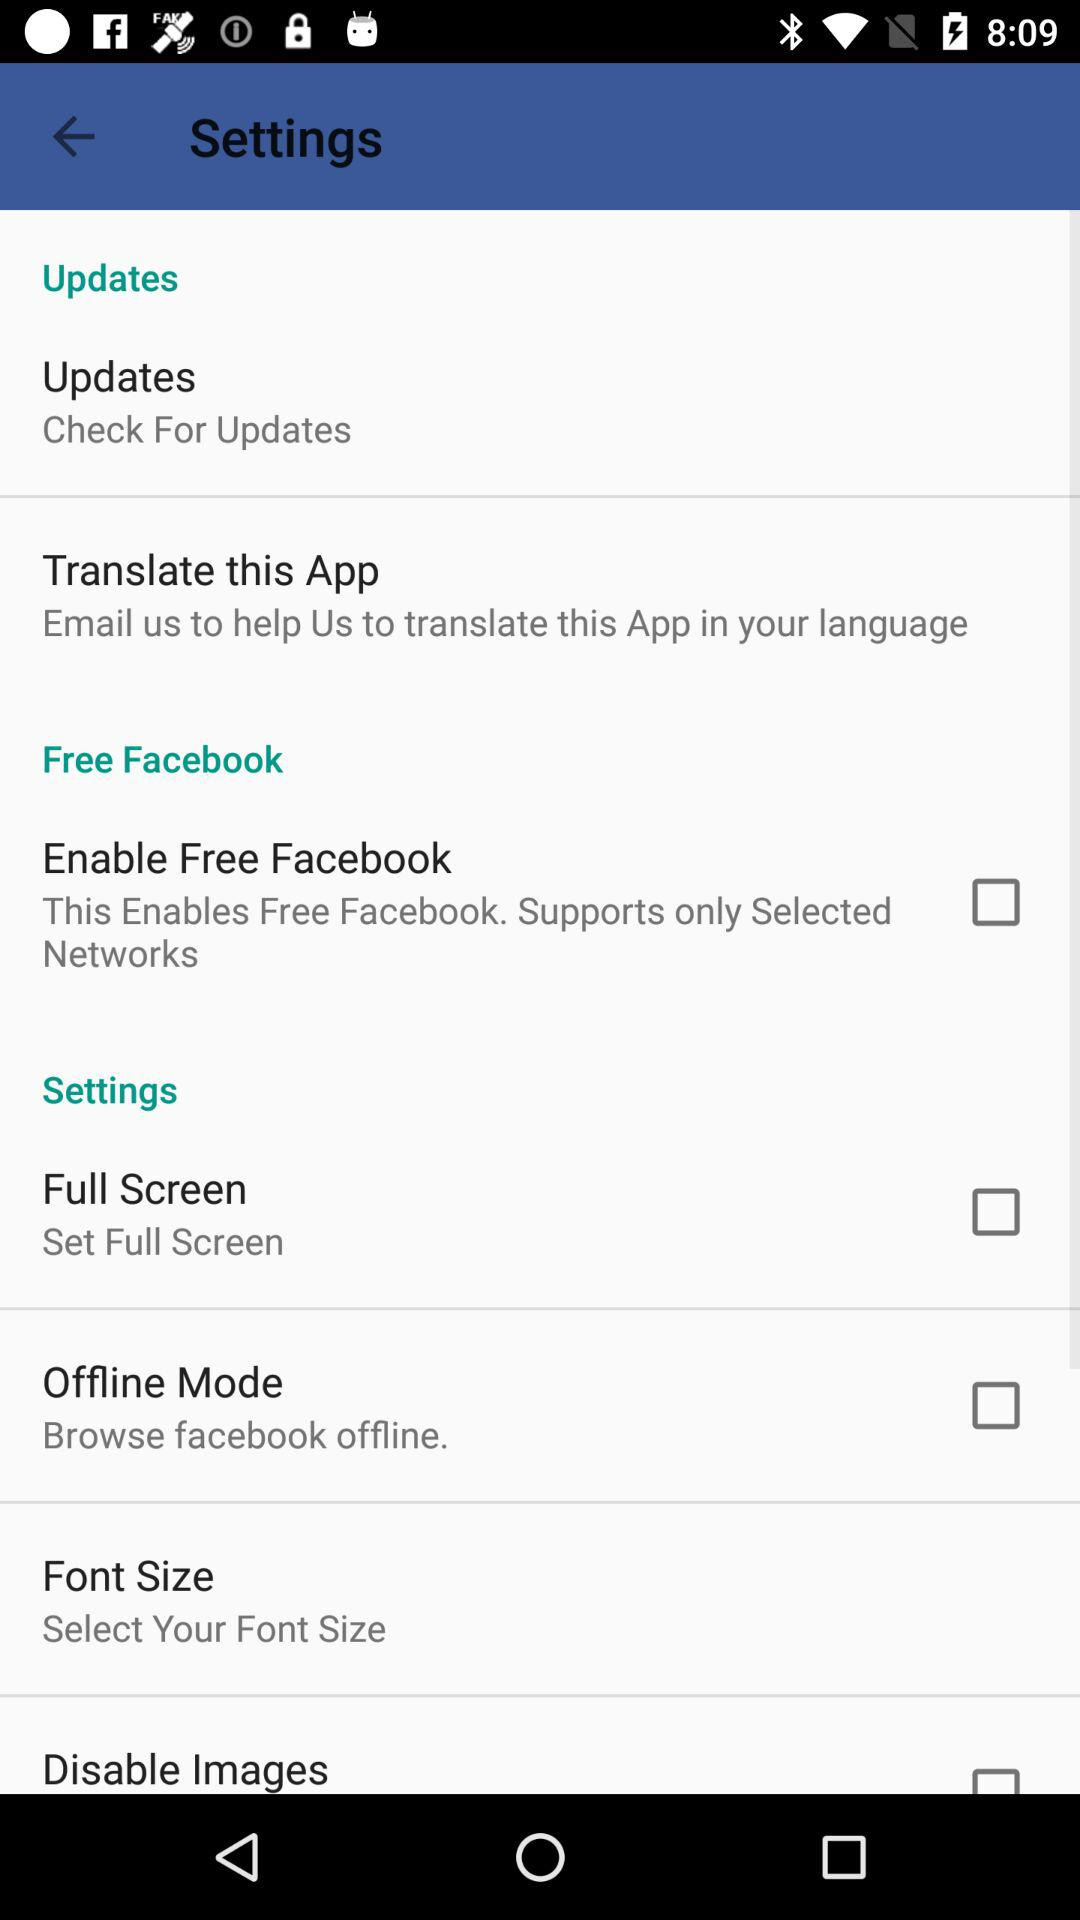What is the status of "Full Screen"? The status of "Full Screen" is "off". 